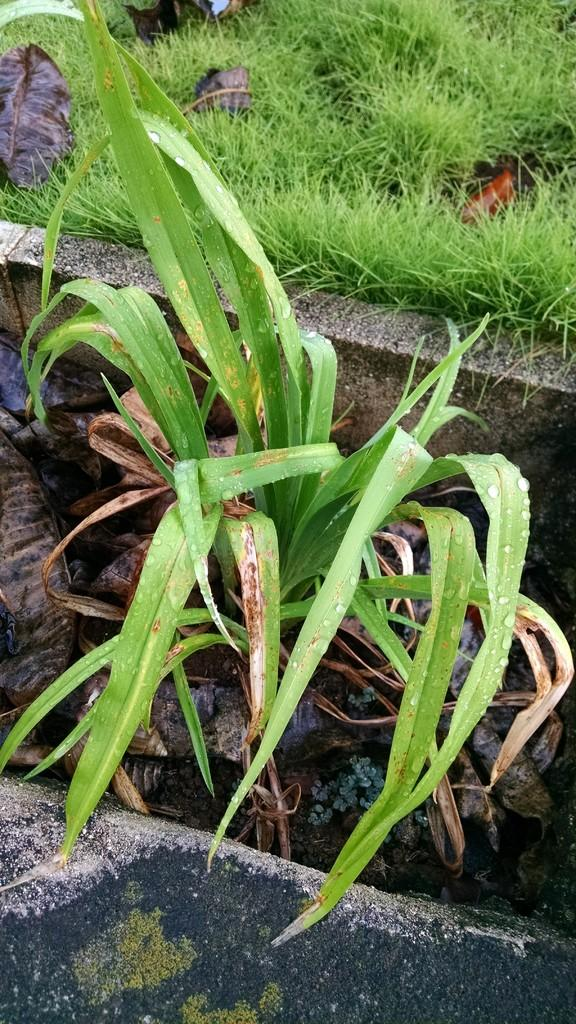What type of vegetation can be seen in the image? There are plants and grass in the image. What is the condition of the leaves in the image? There are dry leaves in the image. What sound does the duck make in the image? There is no duck present in the image, so it cannot make any sound. How many thumbs can be seen in the image? There are no thumbs visible in the image. 